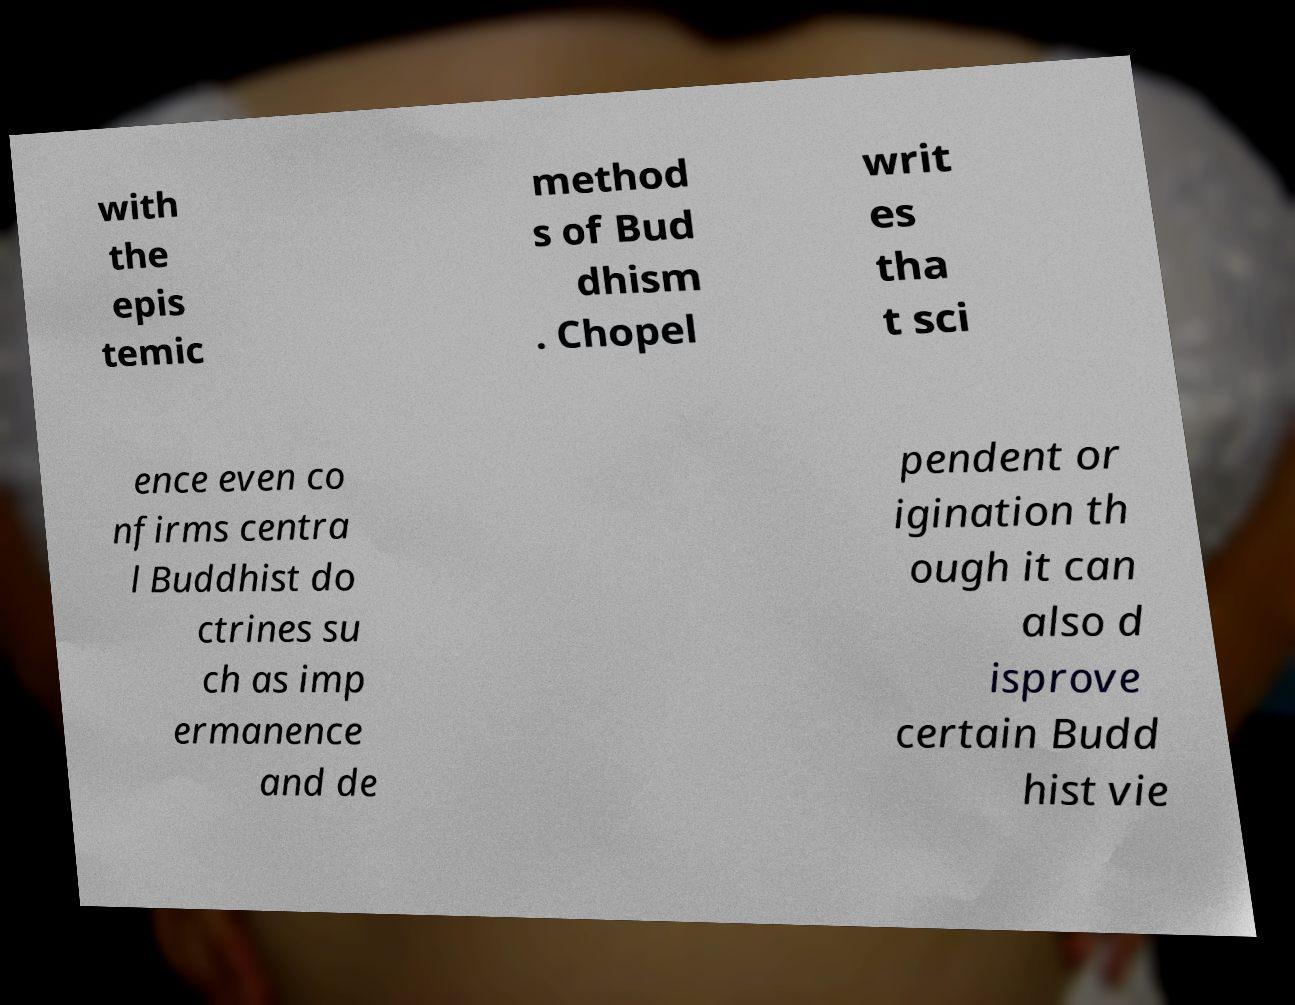What messages or text are displayed in this image? I need them in a readable, typed format. with the epis temic method s of Bud dhism . Chopel writ es tha t sci ence even co nfirms centra l Buddhist do ctrines su ch as imp ermanence and de pendent or igination th ough it can also d isprove certain Budd hist vie 